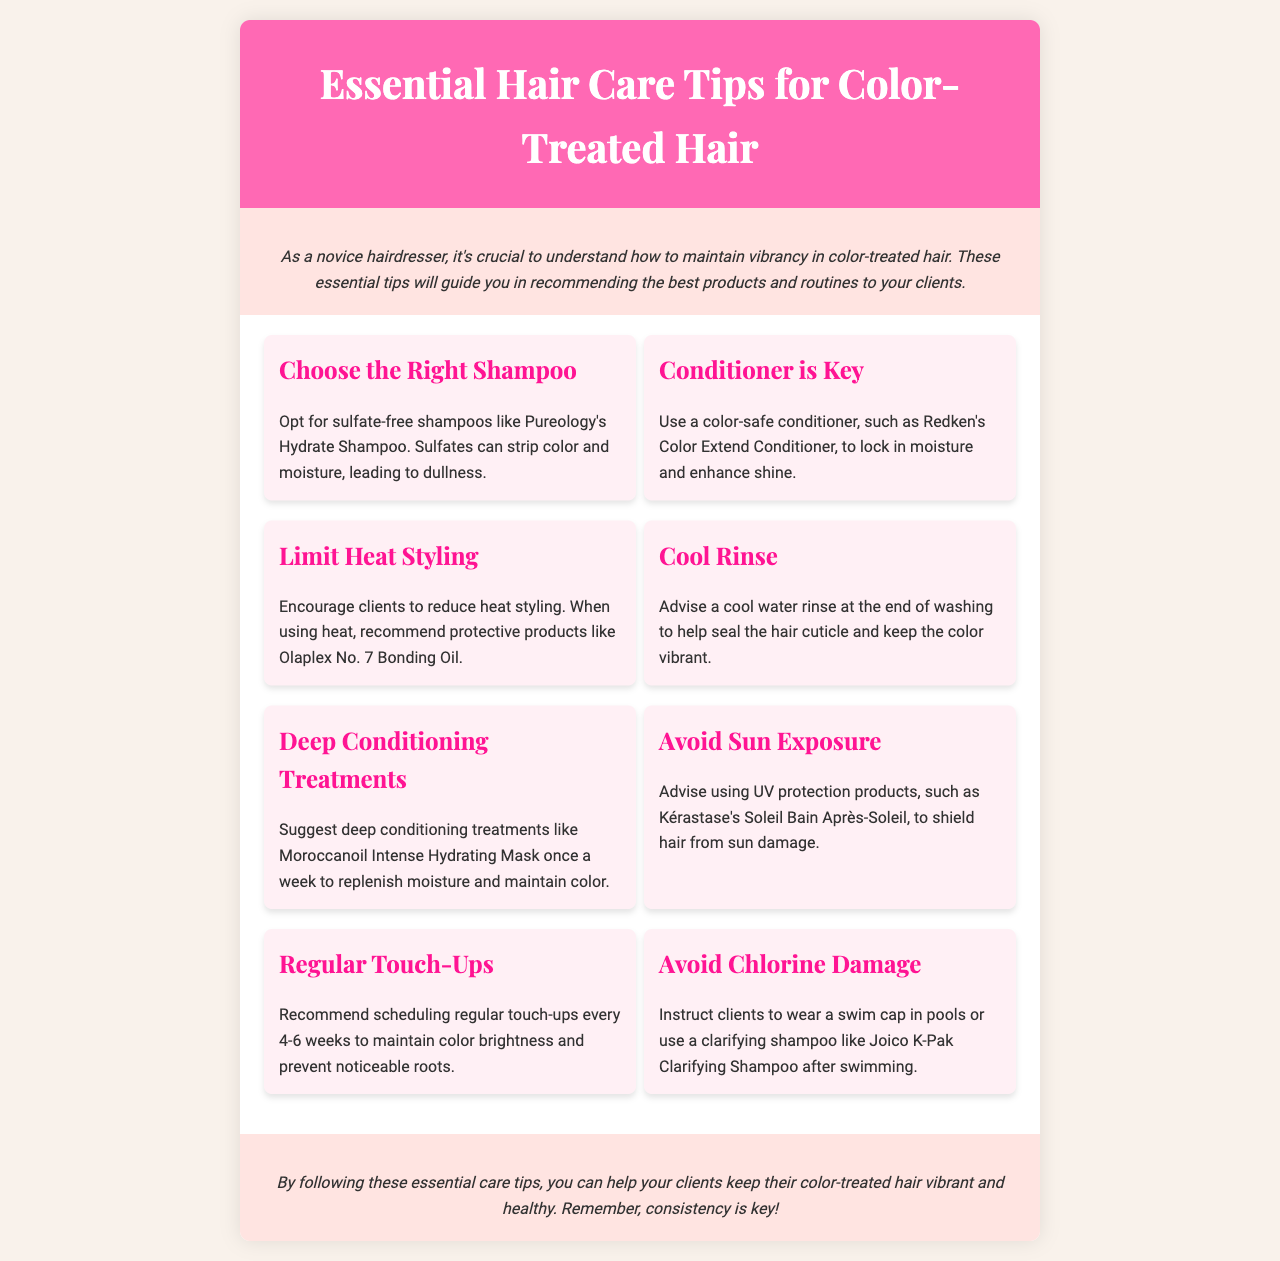What is the title of the brochure? The title is prominently displayed at the top of the document.
Answer: Essential Hair Care Tips for Color-Treated Hair What type of shampoo should be chosen? The brochure specifies the type of shampoo in the first tip.
Answer: sulfate-free Which product is recommended for deep conditioning? The corresponding tip mentions a specific product for deep conditioning.
Answer: Moroccanoil Intense Hydrating Mask How often should touch-ups be scheduled? The regularity of touch-ups is mentioned in the appropriate section of the brochure.
Answer: every 4-6 weeks What is the purpose of a cool rinse? The brochure explains the benefits of a cool rinse in maintaining color vibrancy.
Answer: seal the hair cuticle Why should clients limit heat styling? The reasoning for this recommendation can be found in the section on limiting heat styling.
Answer: reduce dullness What color is the header background? The visual information includes the color used in the header.
Answer: pink What should clients use to protect hair from sun damage? The brochure provides a specific product for UV protection.
Answer: Kérastase's Soleil Bain Après-Soleil 